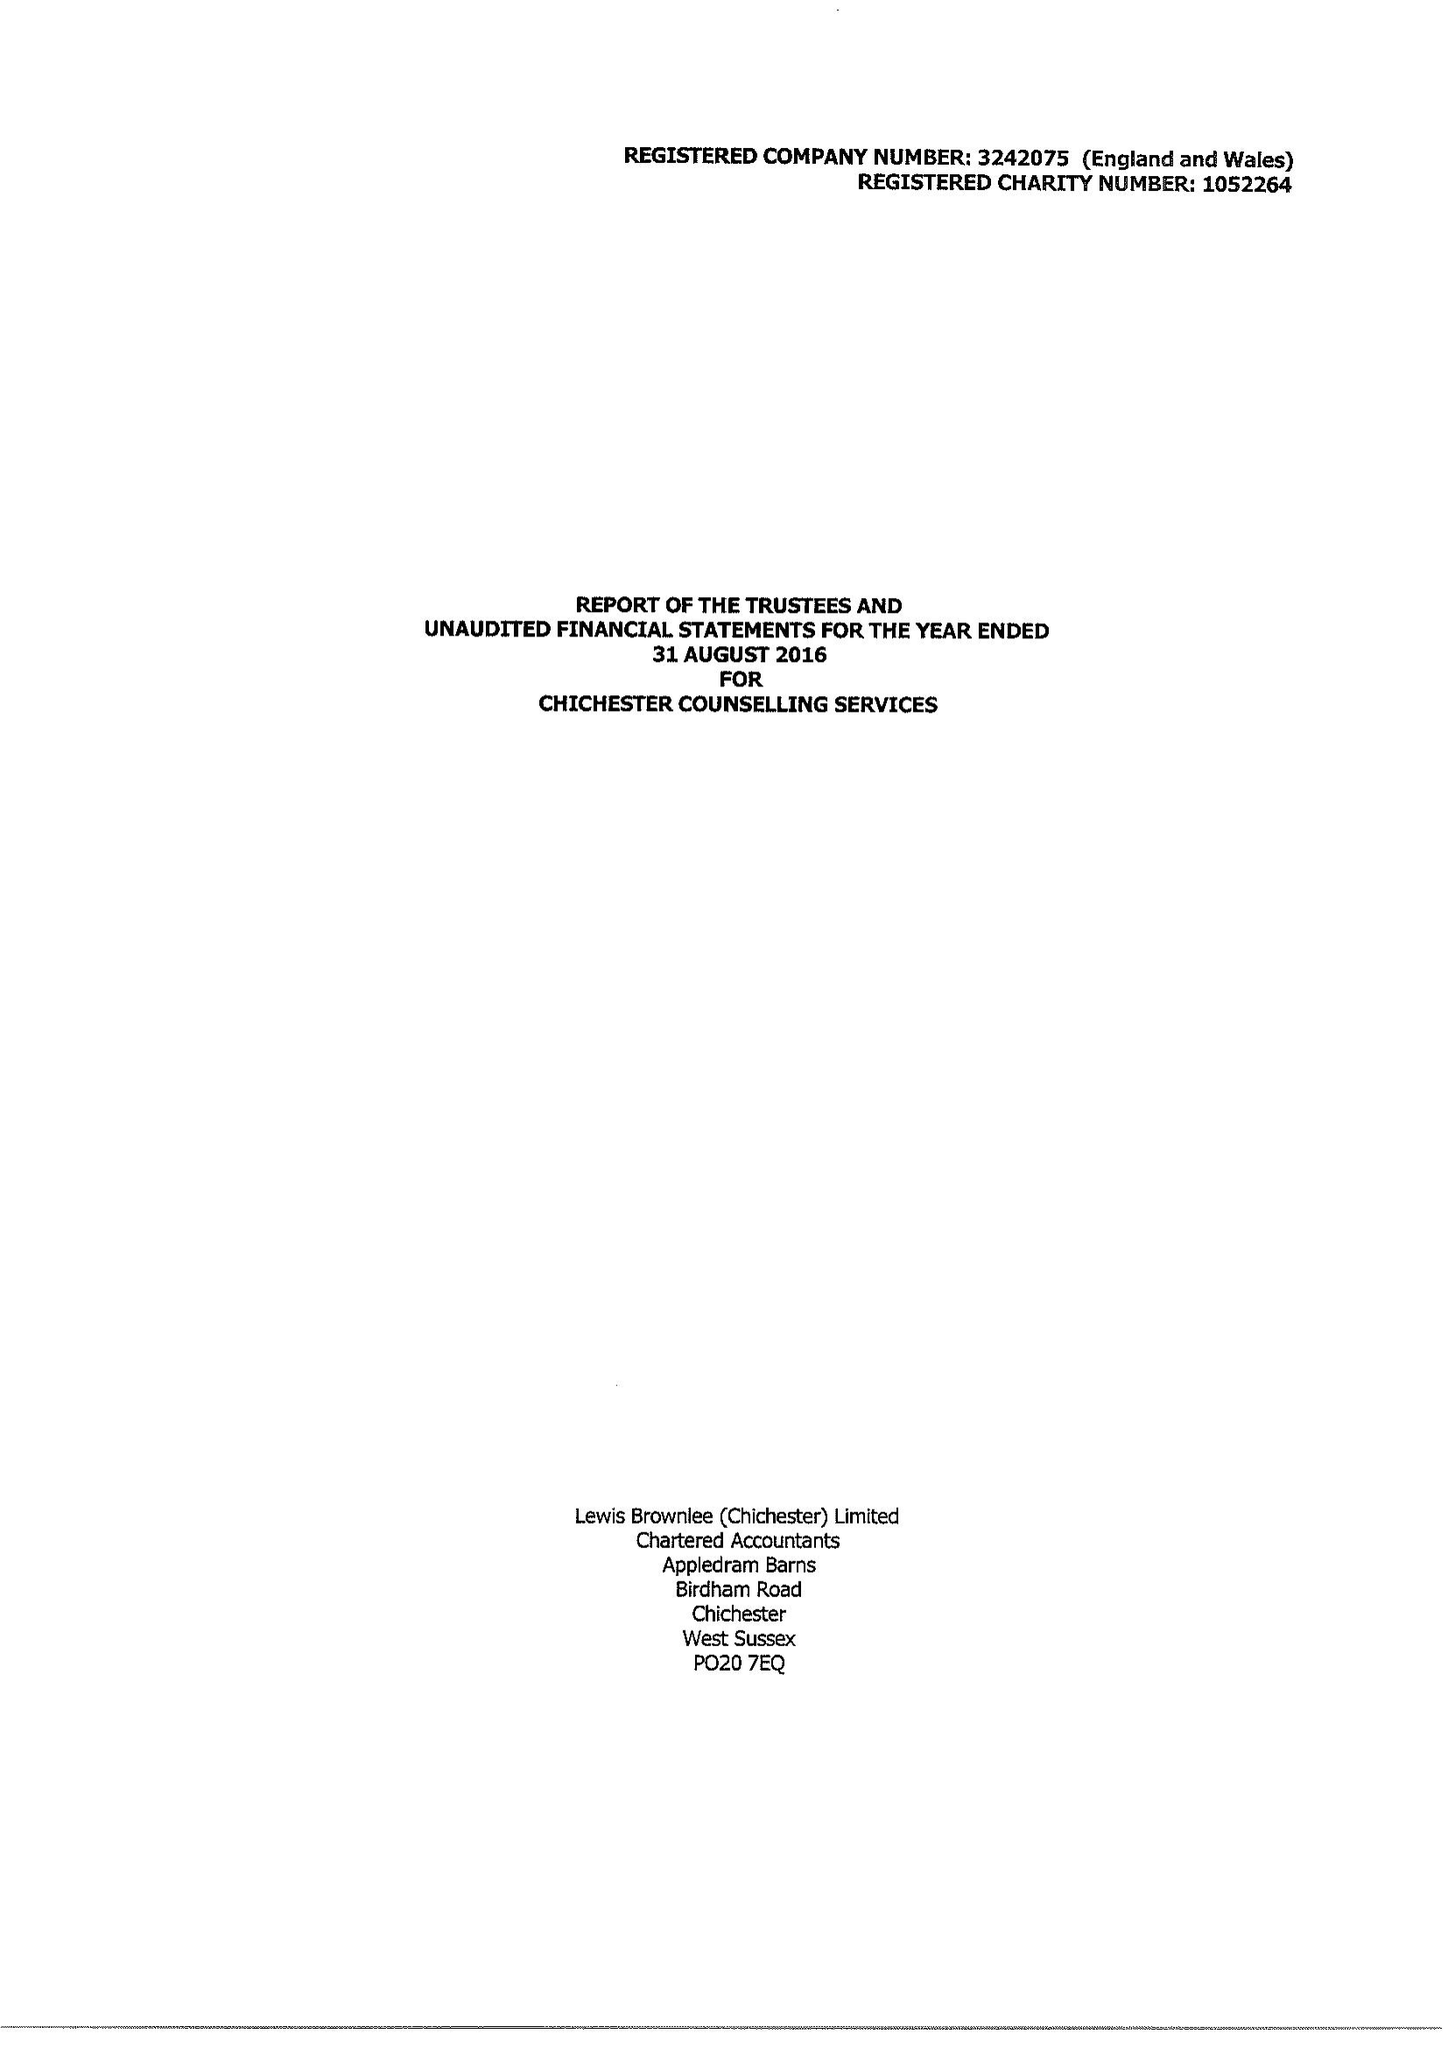What is the value for the address__street_line?
Answer the question using a single word or phrase. None 